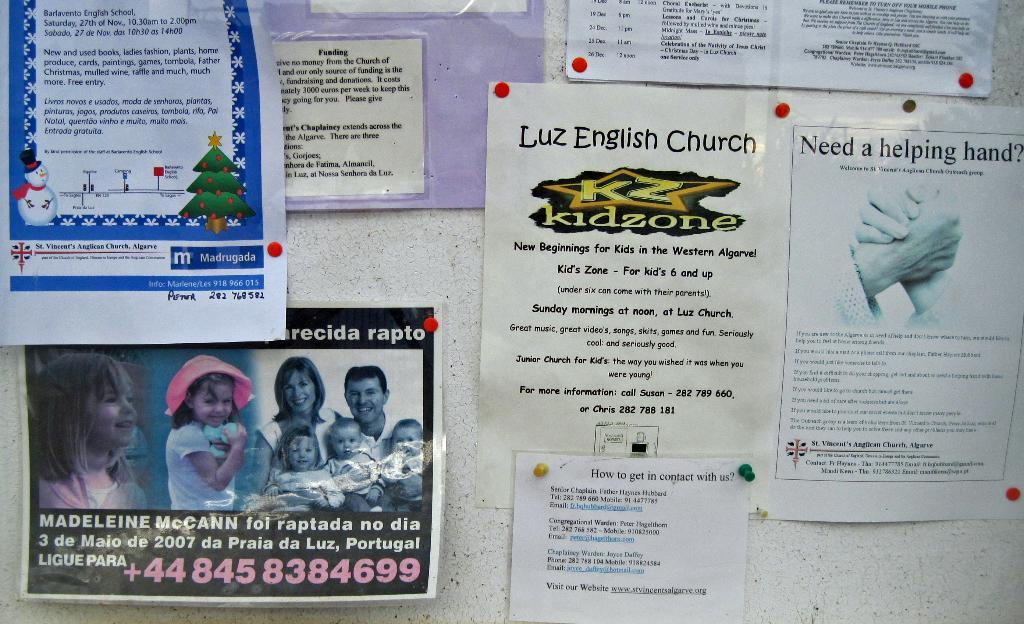<image>
Create a compact narrative representing the image presented. An ad for the kidzone at Luiz English Church lists information about the venue. 